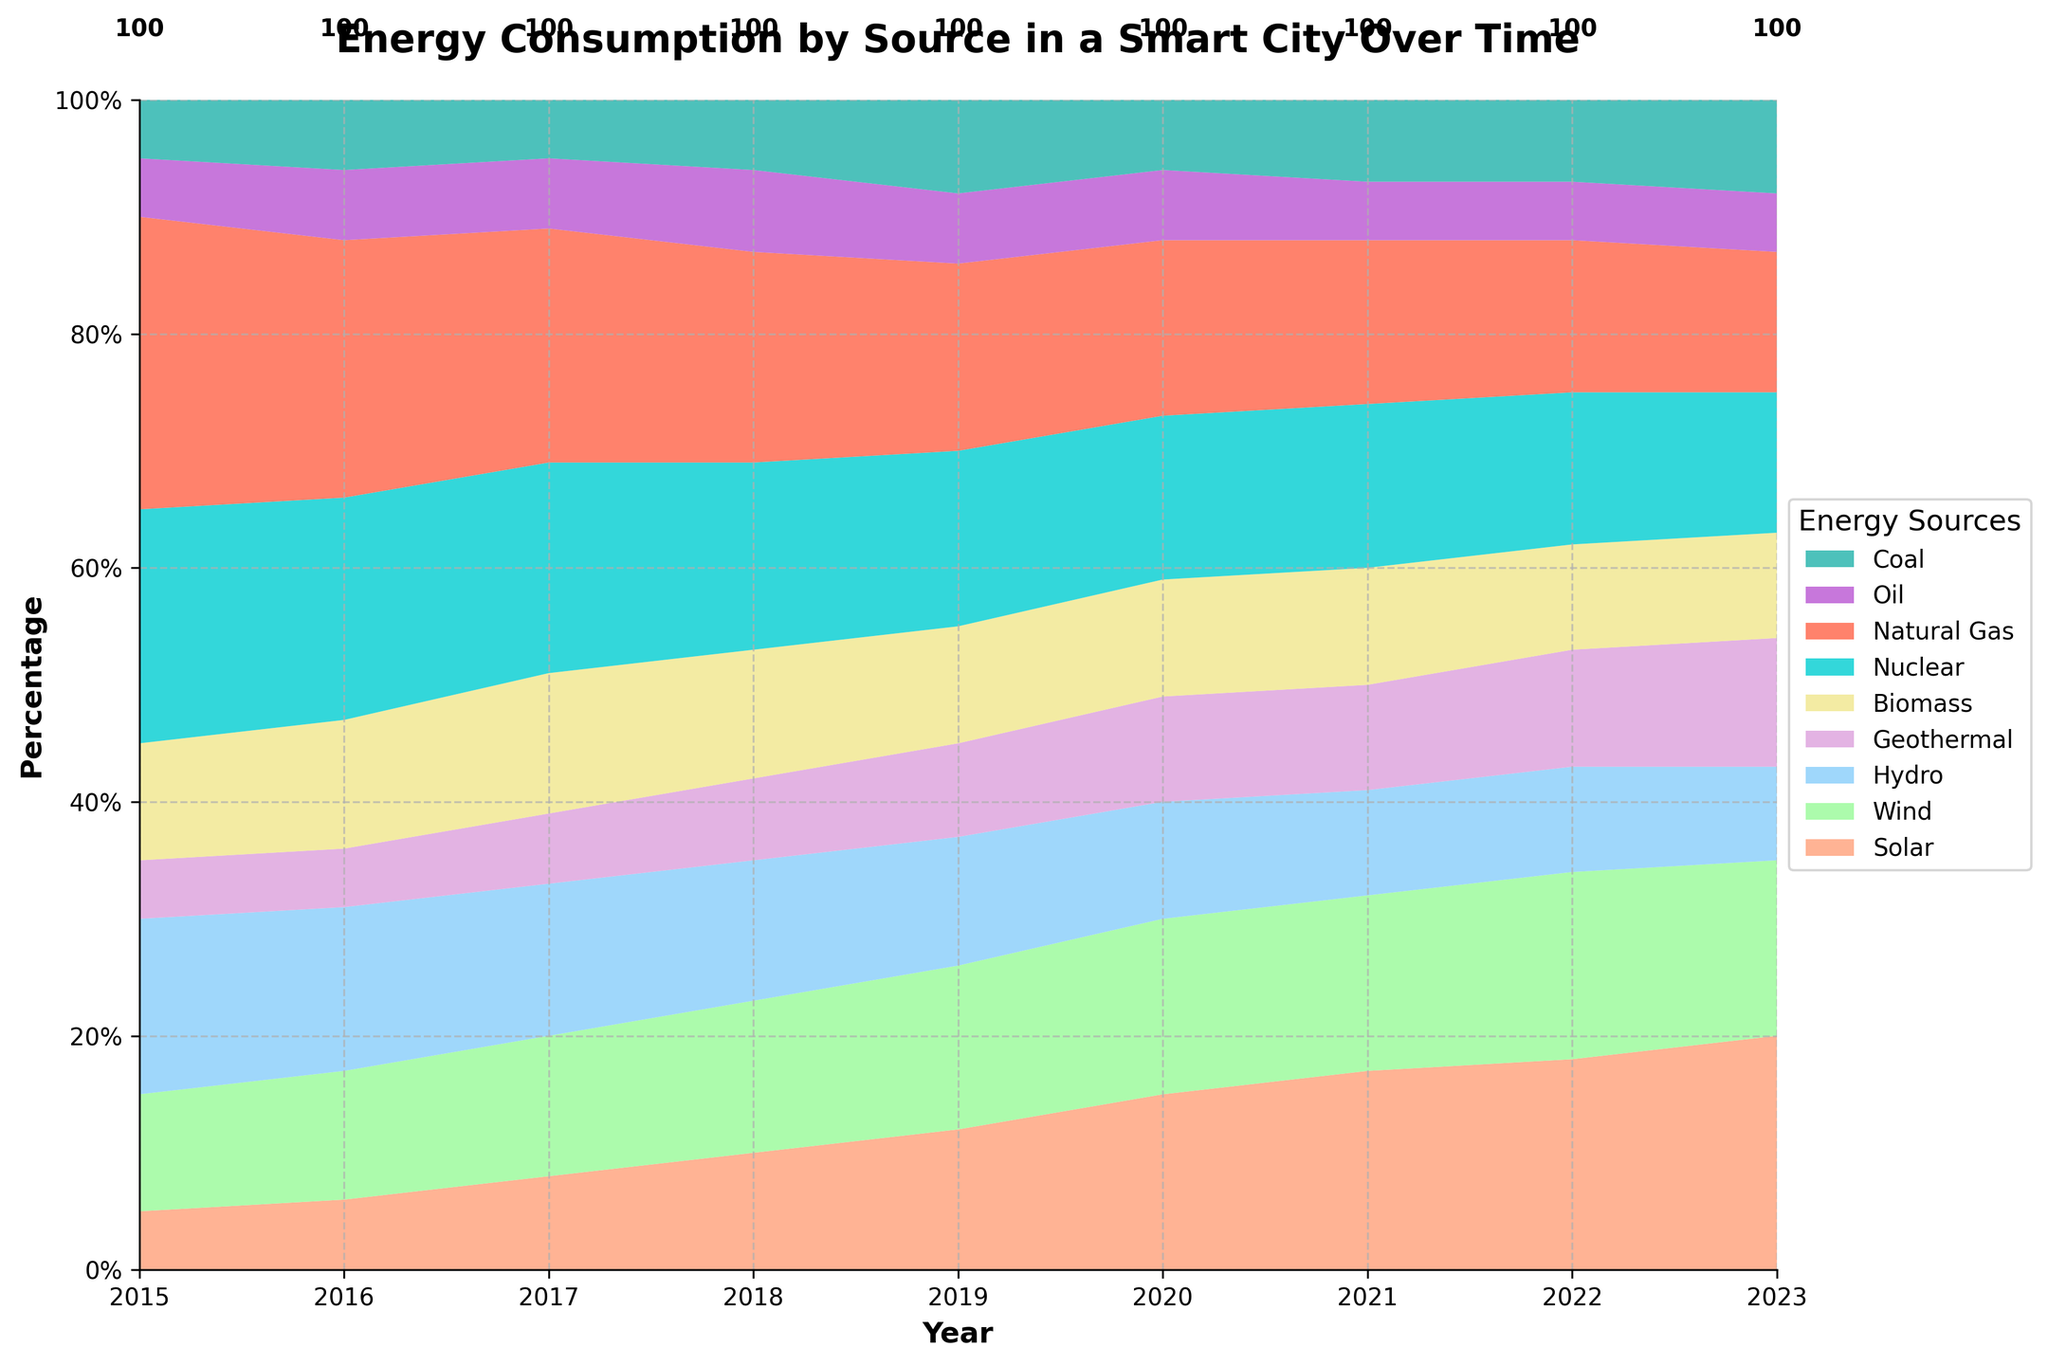What is the title of the figure? The title of the figure is located at the top of the chart, giving an immediate overview of the subject.
Answer: Energy Consumption by Source in a Smart City Over Time What sources make up the majority of the energy consumption over the years? By observing which areas have the largest relative contributions stacked over time, we can see that Natural Gas and Nuclear appear to take up the majority of the chart at most times.
Answer: Natural Gas and Nuclear In which year did Solar energy first exceed 10% of total energy consumption? By visually scanning the different colored segments corresponding to Solar energy, we see that in 2019 the Solar energy segment grows beyond 10% of the total.
Answer: 2019 Compare the contribution of Wind energy to that of Coal in the year 2021. Which one is higher? Looking at the 2021 stack, Wind (green area) appears visually larger compared to Coal (dark green area), indicating that Wind has a higher contribution.
Answer: Wind What is the trend in energy consumption from Solar over the given time period? Observing the placement and growth of the Solar area (orange) over the x-axis years, it increases steadily from a small portion in 2015 to a notable sector in 2023.
Answer: Increasing Between which years did Geothermal energy show the most rapid growth? By visually checking the size of the purple area marked for Geothermal, it shows the most noticeable increase between 2017 and 2019.
Answer: 2017-2019 How did the contribution of Oil change from 2015 to 2023? The size of the Oil segment (light purple) can be tracked over time: it stays relatively constant throughout the period, slightly declining towards the end.
Answer: Slightly declined Which year showed the lowest contribution from Hydro energy? By comparing the areas indicated for Hydro (blue) across all years, the smallest segment appears in 2023.
Answer: 2023 If you sum up the contributions of all renewable energy sources (Solar, Wind, Hydro, Geothermal, Biomass) in 2020, what percentage do they make up? Adding up the respective segments for Solar, Wind, Hydro, Geothermal, and Biomass in the year 2020: 15%+15%+10%+9%+10%=59%.
Answer: 59% In the years 2018 and 2022, which specific energy source had a consistent percentage, and what was that percentage? Observing the chart, Biomass (yellow) remains at 10% in both 2018 and 2022.
Answer: Biomass at 10% 